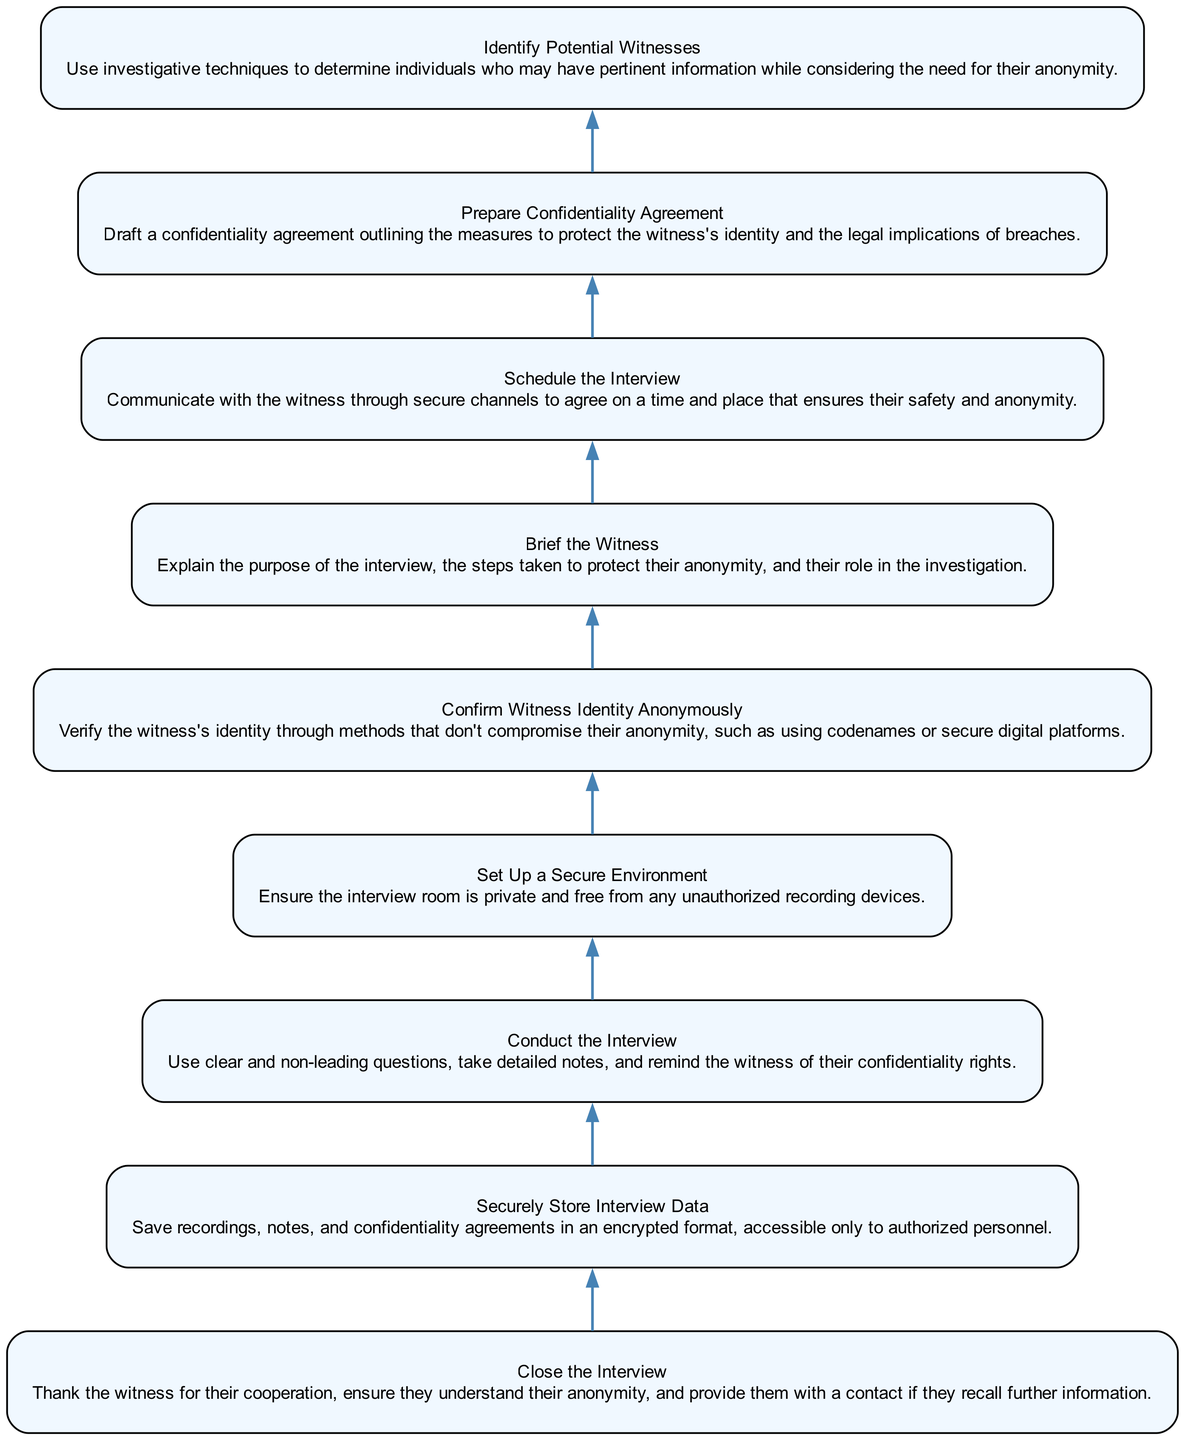What is the first step in the diagram? The first step in the diagram is "Identify Potential Witnesses." It is the first node listed when reading the diagram from the bottom to the top.
Answer: Identify Potential Witnesses How many steps are in the procedure? There are a total of nine steps in the procedure as indicated by the nine distinct nodes in the diagram.
Answer: Nine What step follows "Schedule the Interview"? The step that follows "Schedule the Interview" is "Prepare Confidentiality Agreement." This can be determined by looking at the sequence of the nodes in the diagram.
Answer: Prepare Confidentiality Agreement What is the action taken at the last step? The last step involves "Close the Interview," which includes thanking the witness and providing a contact. This is found at the top of the diagram when reversing the flow from bottom to up.
Answer: Close the Interview What is necessary to confirm witness identity? To confirm witness identity, it is necessary to use methods that don't compromise their anonymity, such as using codenames or secure digital platforms. This is described in the fifth step of the diagram.
Answer: Use codenames or secure digital platforms What is the purpose of the confidentiality agreement? The purpose of the confidentiality agreement is to outline the measures to protect the witness's identity and the legal implications of breaches. This is mentioned in the eighth step and summarizes the importance of the agreement.
Answer: Outline protection measures and legal implications Which step entails the explanation of the interview's purpose? The step that entails explaining the interview's purpose is "Brief the Witness." This step specifically focuses on clarifying the process for the witness.
Answer: Brief the Witness What do you do before conducting the interview? Before conducting the interview, you must "Set Up a Secure Environment," ensuring privacy and safety from unauthorized recording devices. This is a prerequisite step indicated before the interview itself.
Answer: Set Up a Secure Environment 